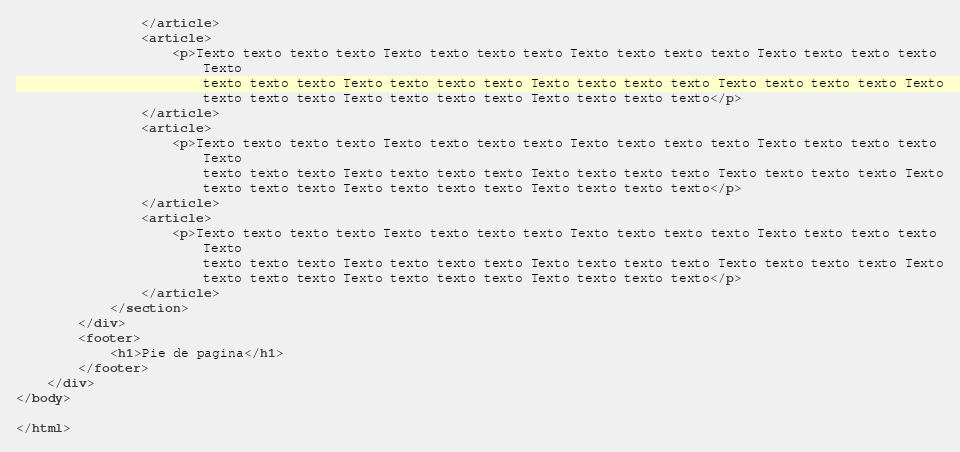Convert code to text. <code><loc_0><loc_0><loc_500><loc_500><_HTML_>                </article>
                <article>
                    <p>Texto texto texto texto Texto texto texto texto Texto texto texto texto Texto texto texto texto
                        Texto
                        texto texto texto Texto texto texto texto Texto texto texto texto Texto texto texto texto Texto
                        texto texto texto Texto texto texto texto Texto texto texto texto</p>
                </article>
                <article>
                    <p>Texto texto texto texto Texto texto texto texto Texto texto texto texto Texto texto texto texto
                        Texto
                        texto texto texto Texto texto texto texto Texto texto texto texto Texto texto texto texto Texto
                        texto texto texto Texto texto texto texto Texto texto texto texto</p>
                </article>
                <article>
                    <p>Texto texto texto texto Texto texto texto texto Texto texto texto texto Texto texto texto texto
                        Texto
                        texto texto texto Texto texto texto texto Texto texto texto texto Texto texto texto texto Texto
                        texto texto texto Texto texto texto texto Texto texto texto texto</p>
                </article>
            </section>
        </div>
        <footer>
            <h1>Pie de pagina</h1>
        </footer>
    </div>
</body>

</html></code> 